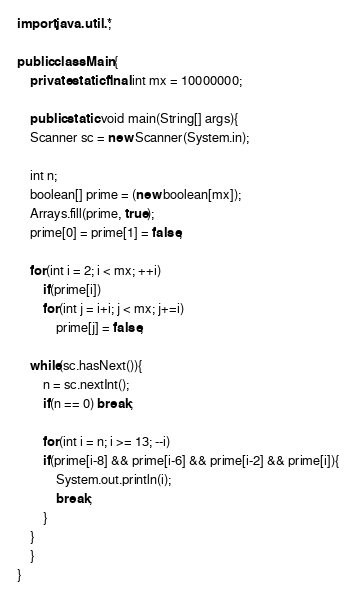Convert code to text. <code><loc_0><loc_0><loc_500><loc_500><_Java_>import java.util.*;

public class Main{
    private static final int mx = 10000000;

    public static void main(String[] args){
	Scanner sc = new Scanner(System.in);

	int n;
	boolean[] prime = (new boolean[mx]);
	Arrays.fill(prime, true);
	prime[0] = prime[1] = false;

	for(int i = 2; i < mx; ++i)
	    if(prime[i])
		for(int j = i+i; j < mx; j+=i)
		    prime[j] = false;
	
	while(sc.hasNext()){
	    n = sc.nextInt();
	    if(n == 0) break;

	    for(int i = n; i >= 13; --i)
		if(prime[i-8] && prime[i-6] && prime[i-2] && prime[i]){
		    System.out.println(i);
		    break;
		}
	}
    }
}</code> 